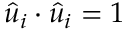Convert formula to latex. <formula><loc_0><loc_0><loc_500><loc_500>{ \hat { u } } _ { i } \cdot { \hat { u } } _ { i } = 1</formula> 